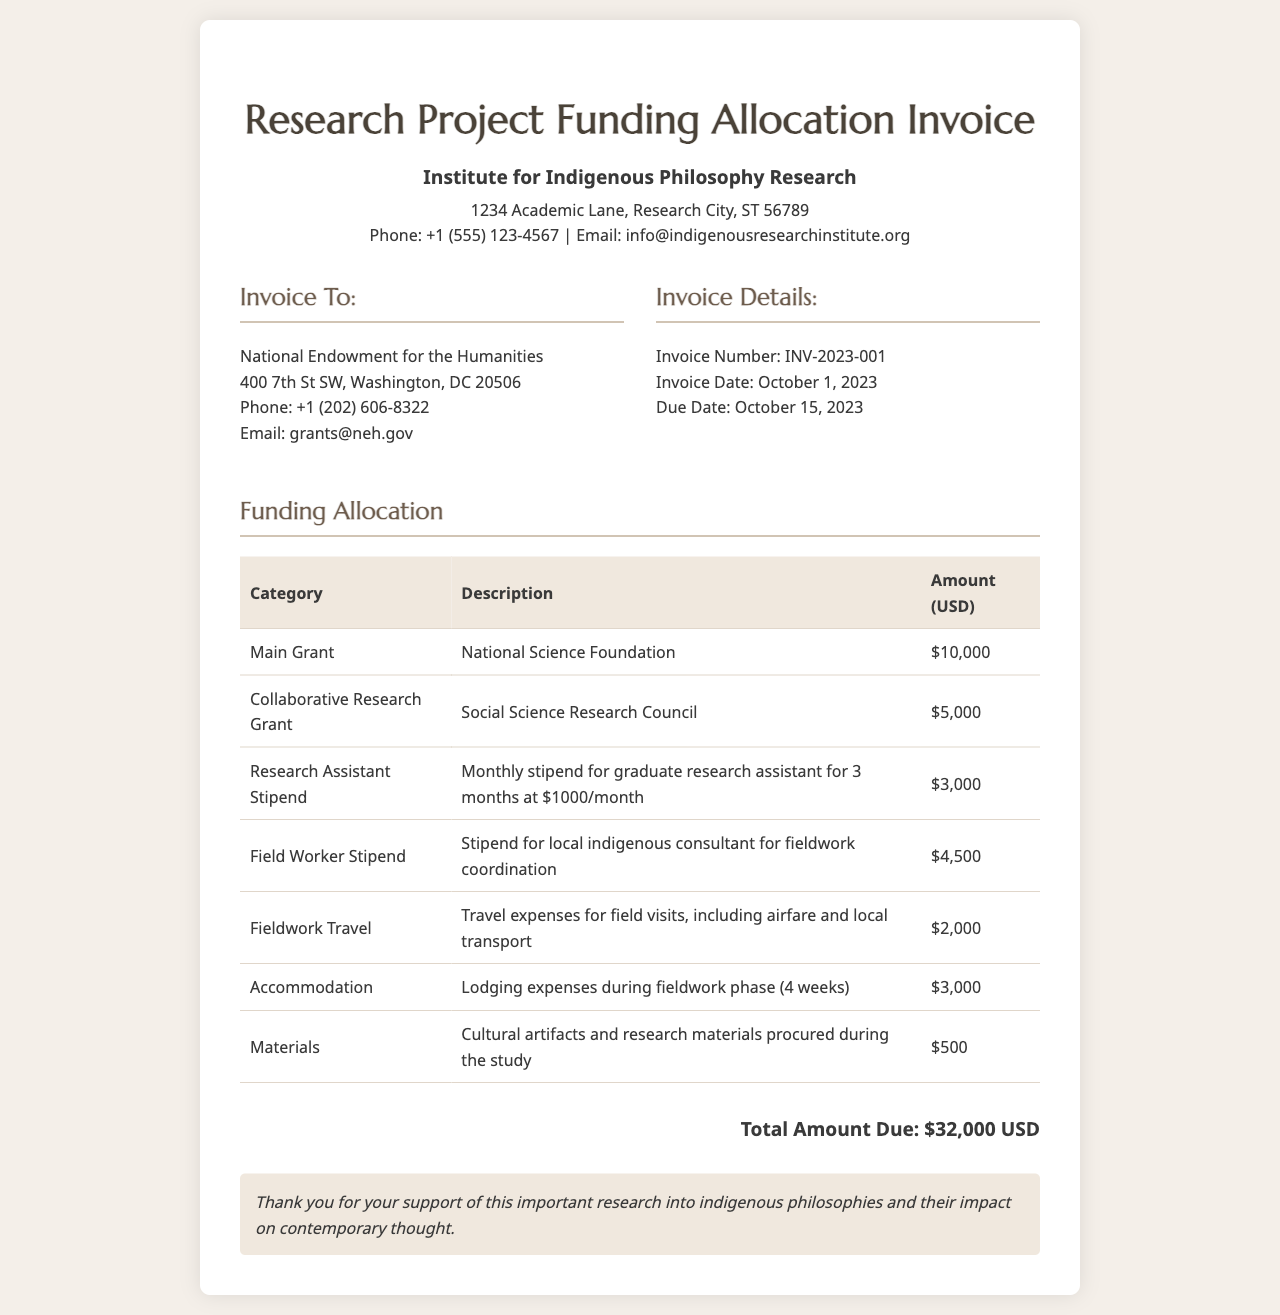What is the invoice number? The invoice number is found in the invoice details section.
Answer: INV-2023-001 Who is the invoice addressed to? The address or recipient for the invoice is specified under the "Invoice To" section.
Answer: National Endowment for the Humanities What is the total amount due? The total amount due is stated at the bottom of the funding allocation section.
Answer: $32,000 USD How much is allocated for the main grant? The amount for the main grant is listed in the funding allocation table.
Answer: $10,000 What is the description of the field worker stipend? The description details are provided in the funding allocation table under the relevant category.
Answer: Stipend for local indigenous consultant for fieldwork coordination How many months is the research assistant stipend calculated for? The calculation of the research assistant stipend depends on the description provided.
Answer: 3 months What are the lodging expenses during fieldwork phase? Lodging expenses are mentioned in the funding allocation table among the expenses.
Answer: $3,000 What type of materials were procured during the study? The materials description indicates what was purchased during the study.
Answer: Cultural artifacts and research materials When is the invoice due date? The due date is specified in the invoice details section.
Answer: October 15, 2023 